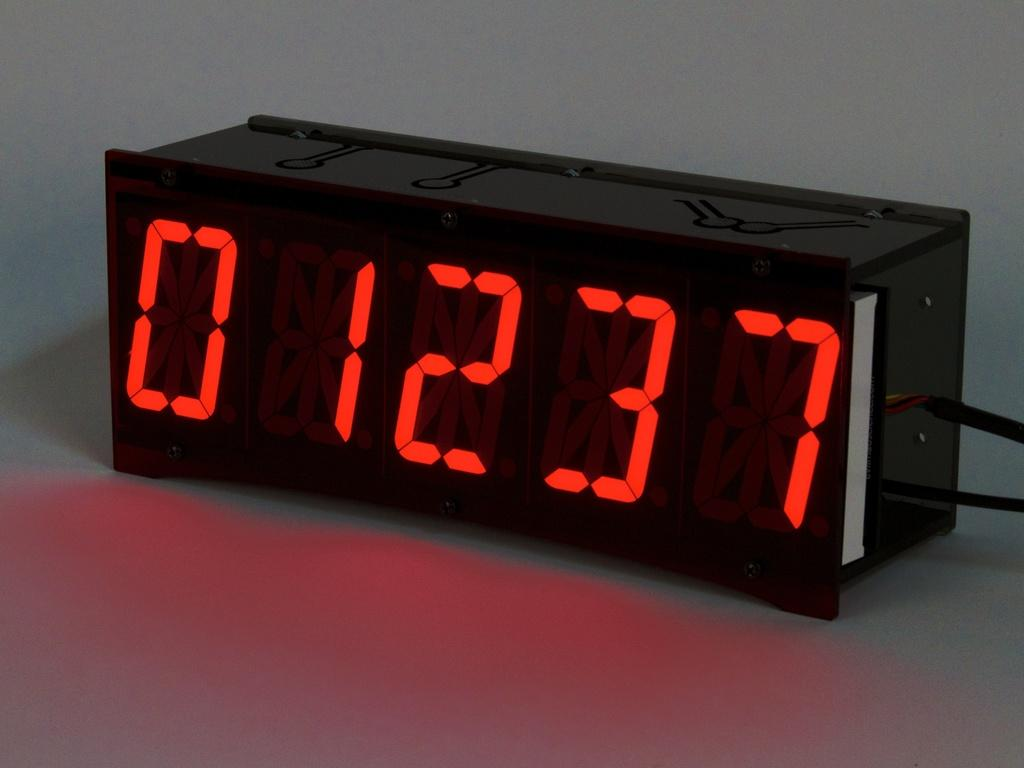<image>
Give a short and clear explanation of the subsequent image. A black clock with red numbers which are 1237. 